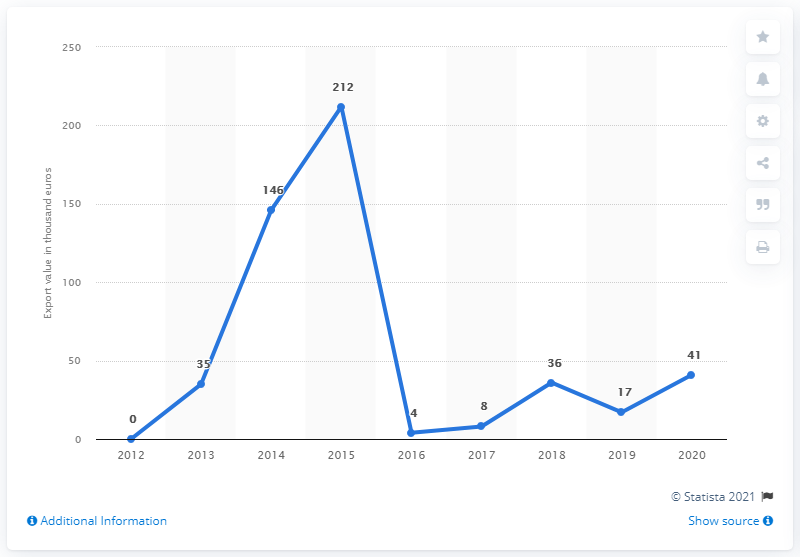Highlight a few significant elements in this photo. The value of wheat gluten exported from Portugal in 2020 was 41. 